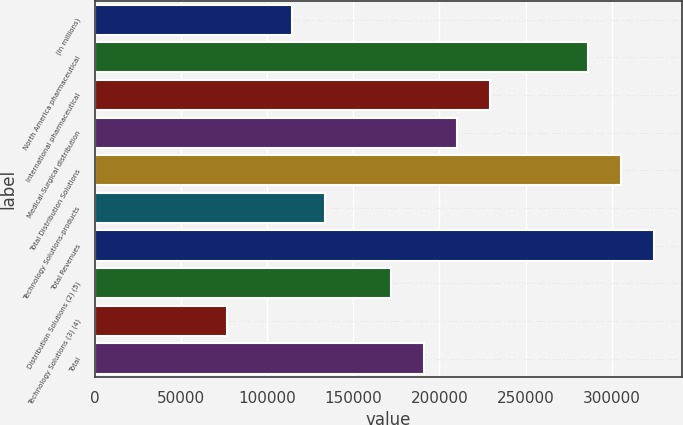<chart> <loc_0><loc_0><loc_500><loc_500><bar_chart><fcel>(In millions)<fcel>North America pharmaceutical<fcel>International pharmaceutical<fcel>Medical-Surgical distribution<fcel>Total Distribution Solutions<fcel>Technology Solutions-products<fcel>Total Revenues<fcel>Distribution Solutions (2) (5)<fcel>Technology Solutions (3) (4)<fcel>Total<nl><fcel>114573<fcel>286272<fcel>229039<fcel>209962<fcel>305350<fcel>133651<fcel>324428<fcel>171806<fcel>76417.8<fcel>190884<nl></chart> 